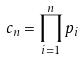<formula> <loc_0><loc_0><loc_500><loc_500>c _ { n } = \prod _ { i = 1 } ^ { n } p _ { i }</formula> 